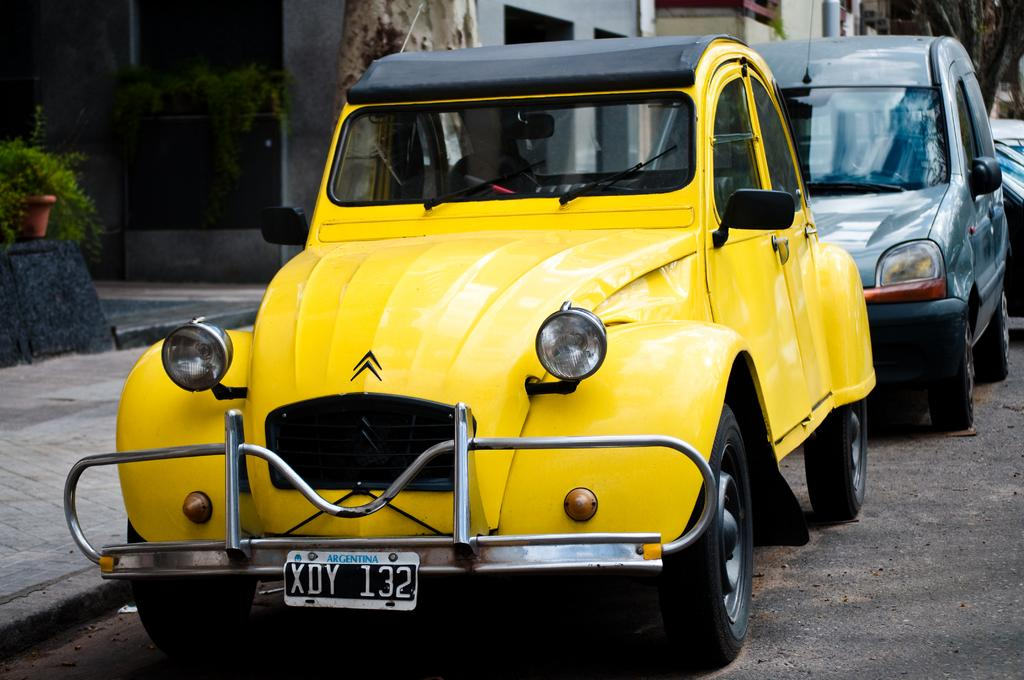<image>
Share a concise interpretation of the image provided. A yellow car is parked by a curb and the license plate says Argentina. 